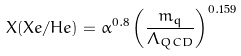<formula> <loc_0><loc_0><loc_500><loc_500>X ( X e / H e ) = \alpha ^ { 0 . 8 } \left ( \frac { m _ { q } } { \Lambda _ { Q C D } } \right ) ^ { 0 . 1 5 9 }</formula> 